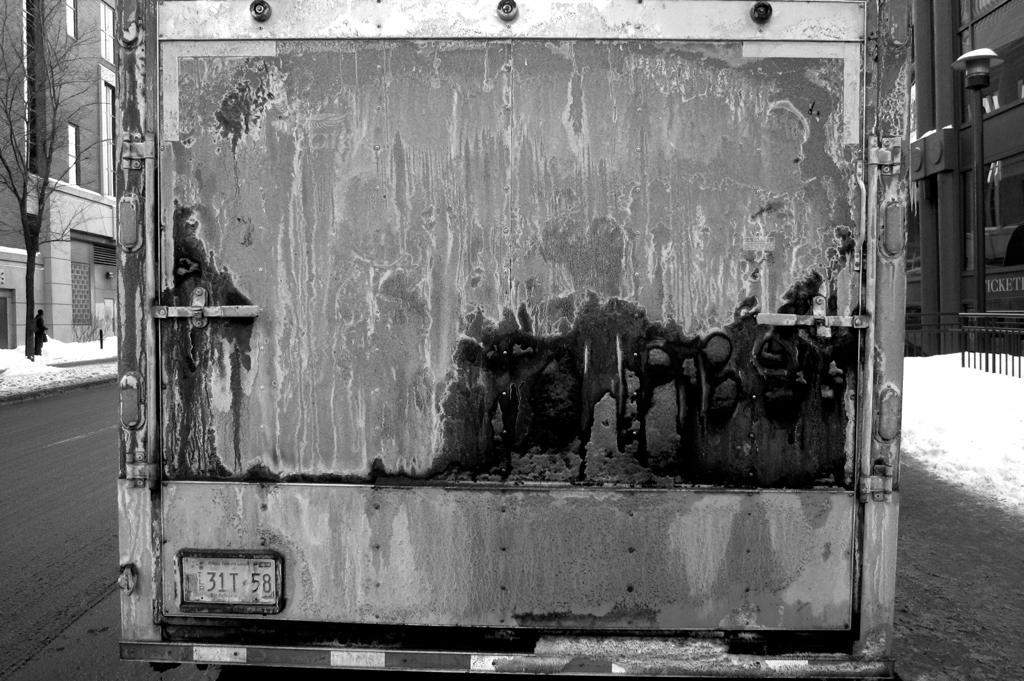Can you describe this image briefly? In this picture we can observe a vehicle on the road. There is some snow on either sides of the road. We can observe tree on the left side. There are some buildings and a poll on the right side. This is a black and white image. 